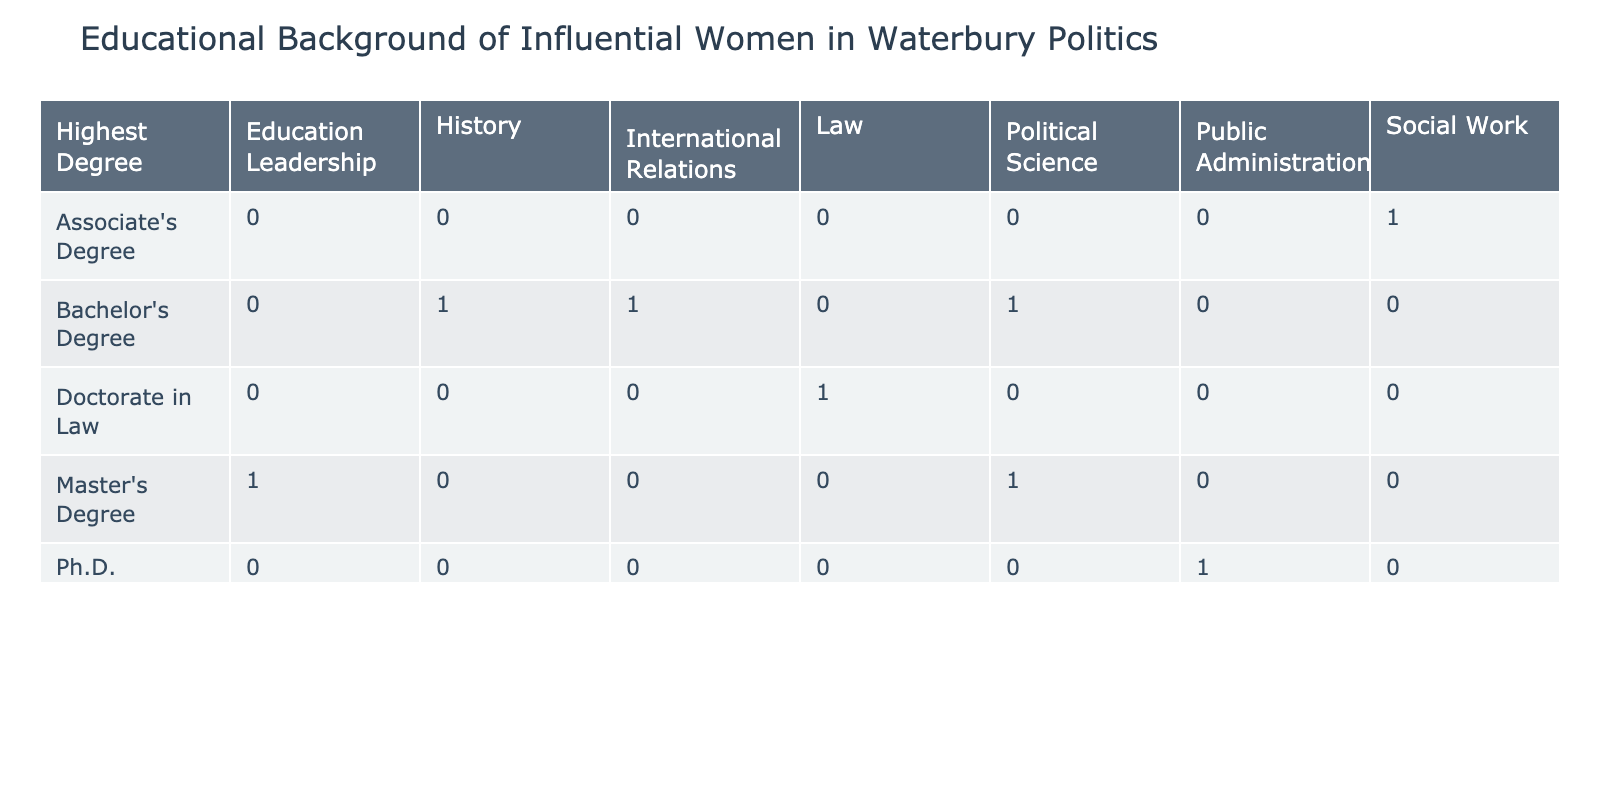What is the most common highest degree among the women listed? By examining the 'Highest Degree' row in the table, we can count instances for each degree. The Master's Degree appears 3 times, Bachelor's Degree appears 3 times, and there is 1 each of Ph.D., Associate's Degree, and Doctorate in Law. Therefore, there is a tie between Master's and Bachelor's Degrees as the most common.
Answer: Master's Degree and Bachelor's Degree Which field of study has the highest number of women graduates? Looking through the fields of study columns, we observe the frequency of each field. Political Science is listed twice: once in a Bachelor's degree and once in a Doctorate. Education Leadership, History, Public Administration, Social Work, and International Relations are each only represented once. The field that has the most graduates listed in the table is Political Science.
Answer: Political Science Are there any women who graduated with an Associate's Degree? Checking the table for the 'Highest Degree' column reveals that there is one woman listed with an Associate's Degree, specifically Linda F. Shelton.
Answer: Yes What percentage of graduates hold a Ph.D.? To find the percentage of graduates with a Ph.D., we first note that there are a total of 8 graduates in the table. There is one individual listed with a Ph.D., which gives us (1/8) * 100 = 12.5%.
Answer: 12.5% Which institution had the highest number of graduates represented? Checking the institutions, we list how many graduates each has. Yale University has 1, UConn-Storrs has 1, Columbia University has 1, Naugatuck Valley Community College has 1, Wesleyan University has 1, University of Connecticut has 1, Harvard Law School has 1, and Southern Connecticut State University has 1. There is no institution with more than one graduate.
Answer: None, all institutions have 1 graduate How many women graduated with a law degree? Looking at the table, we check the 'Field of Study' column for Law. We see that Sarah E. Mitchell is the only one listed under Law.
Answer: 1 What is the relationship between the highest degree and the field of study for those who graduated from Yale? The only woman listed with a degree from Yale is Anna Z. Smiley, who holds a Master's Degree in Political Science. Thus, the relationship is that graduated with a Master's Degree in Political Science.
Answer: Master's Degree in Political Science Is there a woman with a Doctorate degree in the field of Education? Reviewing the table under the 'Highest Degree' and 'Field of Study', we find that the only Doctorate listed is Sarah E. Mitchell, who specializes in Law. No women hold a Doctorate in Education, as Patricia A. Collins graduated with a Master's Degree in Education Leadership instead.
Answer: No 